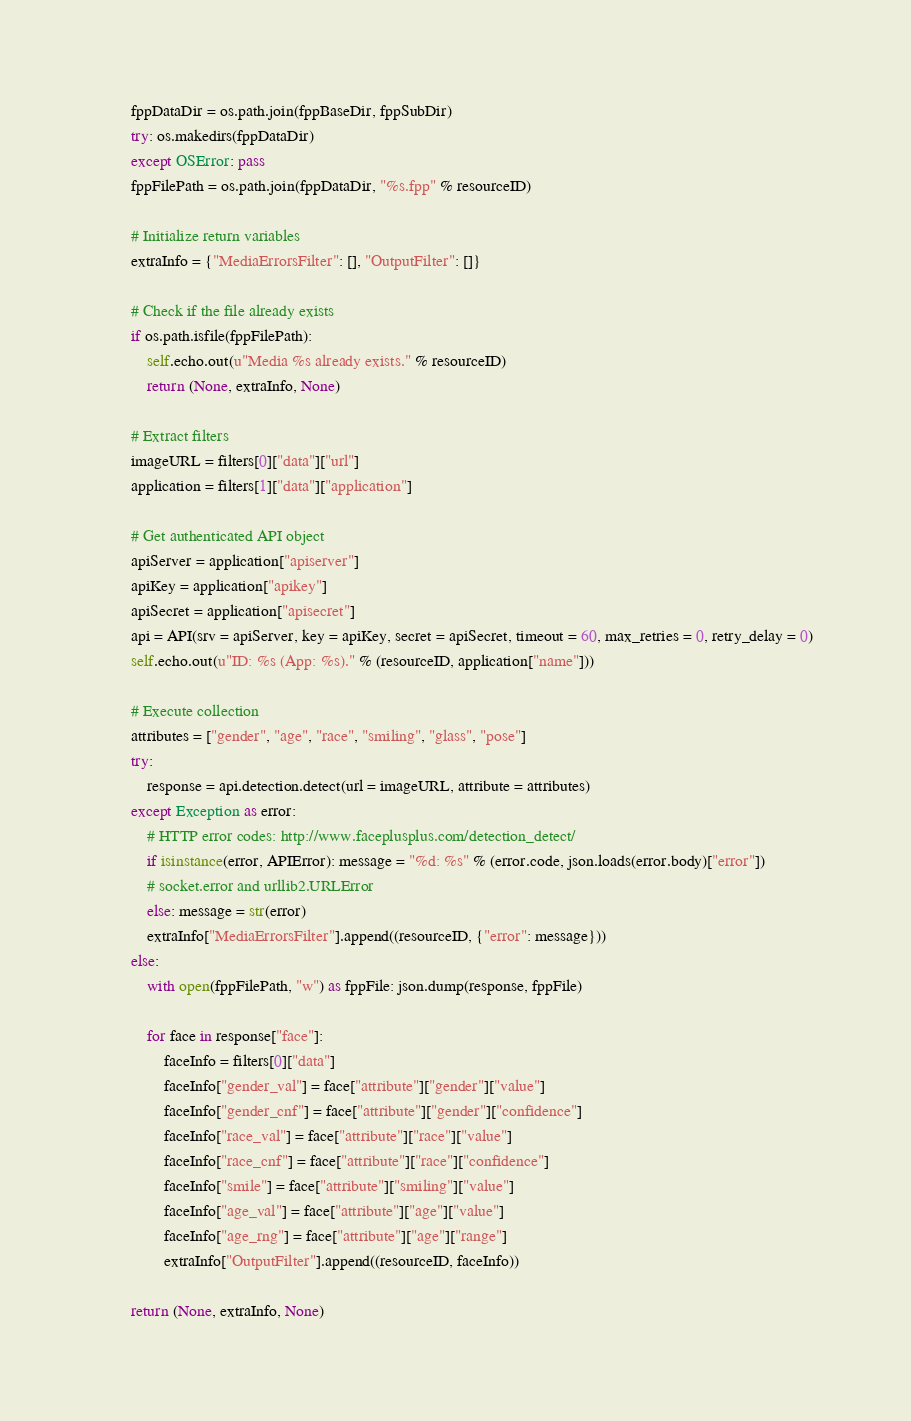<code> <loc_0><loc_0><loc_500><loc_500><_Python_>        fppDataDir = os.path.join(fppBaseDir, fppSubDir)
        try: os.makedirs(fppDataDir)
        except OSError: pass
        fppFilePath = os.path.join(fppDataDir, "%s.fpp" % resourceID)
        
        # Initialize return variables
        extraInfo = {"MediaErrorsFilter": [], "OutputFilter": []}
        
        # Check if the file already exists
        if os.path.isfile(fppFilePath): 
            self.echo.out(u"Media %s already exists." % resourceID)
            return (None, extraInfo, None)
        
        # Extract filters
        imageURL = filters[0]["data"]["url"]
        application = filters[1]["data"]["application"]
    
        # Get authenticated API object
        apiServer = application["apiserver"]
        apiKey = application["apikey"]
        apiSecret = application["apisecret"]
        api = API(srv = apiServer, key = apiKey, secret = apiSecret, timeout = 60, max_retries = 0, retry_delay = 0)
        self.echo.out(u"ID: %s (App: %s)." % (resourceID, application["name"]))
        
        # Execute collection
        attributes = ["gender", "age", "race", "smiling", "glass", "pose"]
        try:
            response = api.detection.detect(url = imageURL, attribute = attributes)
        except Exception as error: 
            # HTTP error codes: http://www.faceplusplus.com/detection_detect/
            if isinstance(error, APIError): message = "%d: %s" % (error.code, json.loads(error.body)["error"])
            # socket.error and urllib2.URLError 
            else: message = str(error)
            extraInfo["MediaErrorsFilter"].append((resourceID, {"error": message}))
        else: 
            with open(fppFilePath, "w") as fppFile: json.dump(response, fppFile)
            
            for face in response["face"]:
                faceInfo = filters[0]["data"]
                faceInfo["gender_val"] = face["attribute"]["gender"]["value"]
                faceInfo["gender_cnf"] = face["attribute"]["gender"]["confidence"]
                faceInfo["race_val"] = face["attribute"]["race"]["value"]
                faceInfo["race_cnf"] = face["attribute"]["race"]["confidence"]
                faceInfo["smile"] = face["attribute"]["smiling"]["value"]
                faceInfo["age_val"] = face["attribute"]["age"]["value"]
                faceInfo["age_rng"] = face["attribute"]["age"]["range"]
                extraInfo["OutputFilter"].append((resourceID, faceInfo))
        
        return (None, extraInfo, None)        
</code> 